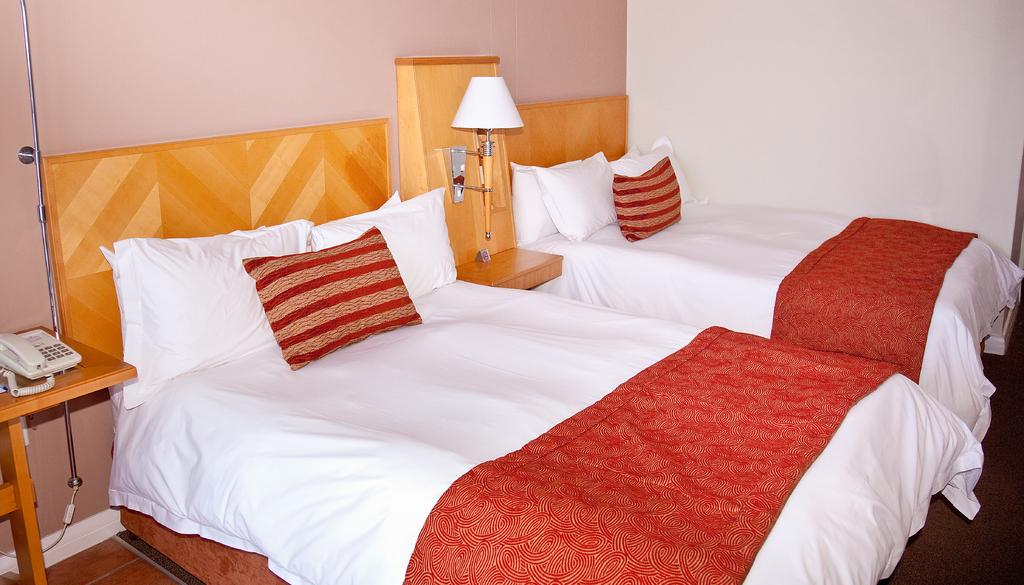How many beds are in the image? There are two beds in the image. What can be found on the beds? There are pillows on the beds. What is located near the bed? There is a telephone and a lamp near the bed. Can you describe the crowd gathered outside the window in the image? There is no crowd or window present in the image; it only features two beds with pillows, a telephone, and a lamp. 